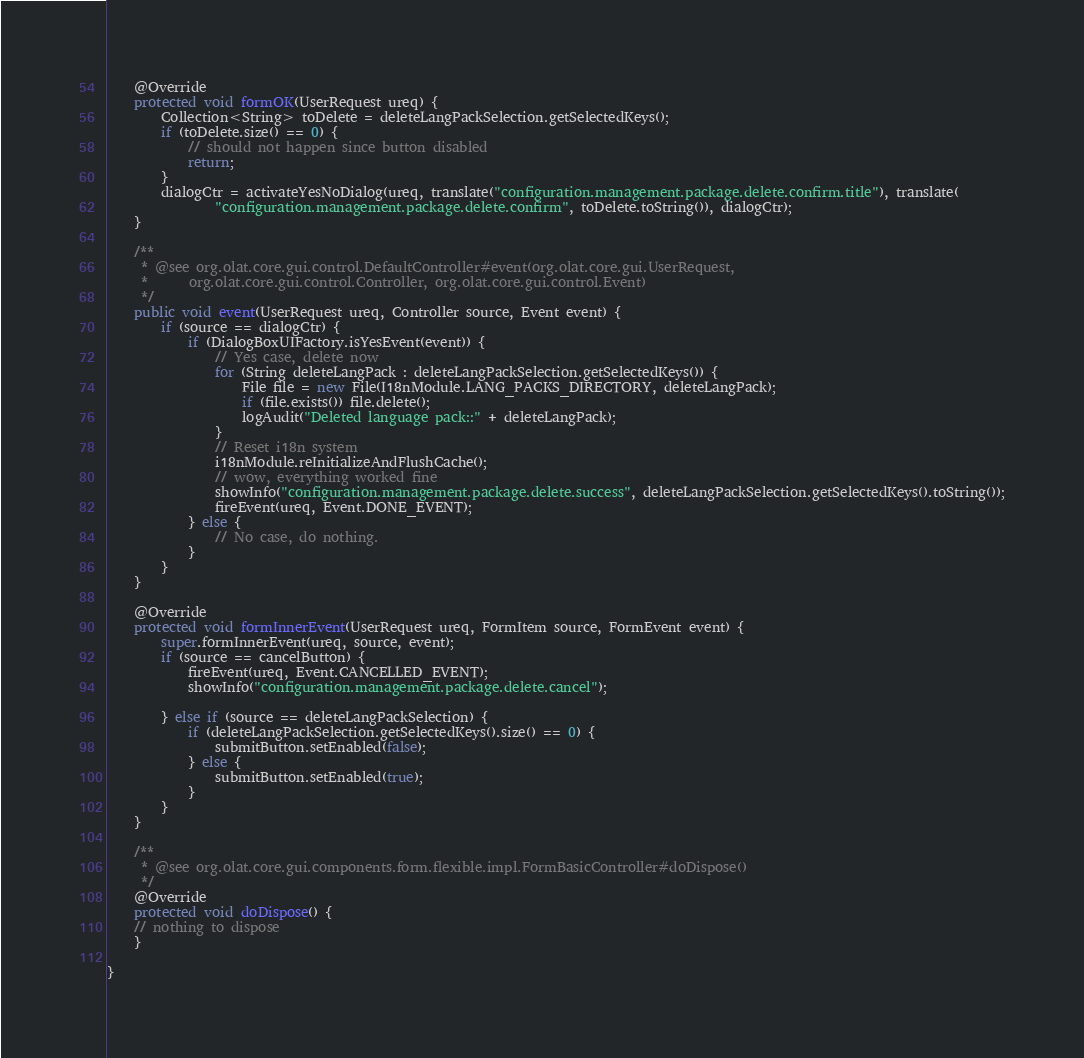<code> <loc_0><loc_0><loc_500><loc_500><_Java_>	@Override
	protected void formOK(UserRequest ureq) {
		Collection<String> toDelete = deleteLangPackSelection.getSelectedKeys();
		if (toDelete.size() == 0) {
			// should not happen since button disabled
			return;
		}
		dialogCtr = activateYesNoDialog(ureq, translate("configuration.management.package.delete.confirm.title"), translate(
				"configuration.management.package.delete.confirm", toDelete.toString()), dialogCtr);
	}

	/**
	 * @see org.olat.core.gui.control.DefaultController#event(org.olat.core.gui.UserRequest,
	 *      org.olat.core.gui.control.Controller, org.olat.core.gui.control.Event)
	 */
	public void event(UserRequest ureq, Controller source, Event event) {
		if (source == dialogCtr) {
			if (DialogBoxUIFactory.isYesEvent(event)) {
				// Yes case, delete now
				for (String deleteLangPack : deleteLangPackSelection.getSelectedKeys()) {
					File file = new File(I18nModule.LANG_PACKS_DIRECTORY, deleteLangPack);
					if (file.exists()) file.delete();
					logAudit("Deleted language pack::" + deleteLangPack);
				}
				// Reset i18n system
				i18nModule.reInitializeAndFlushCache();
				// wow, everything worked fine
				showInfo("configuration.management.package.delete.success", deleteLangPackSelection.getSelectedKeys().toString());
				fireEvent(ureq, Event.DONE_EVENT);
			} else {
				// No case, do nothing.
			}
		}
	}

	@Override
	protected void formInnerEvent(UserRequest ureq, FormItem source, FormEvent event) {
		super.formInnerEvent(ureq, source, event);
		if (source == cancelButton) {
			fireEvent(ureq, Event.CANCELLED_EVENT);
			showInfo("configuration.management.package.delete.cancel");

		} else if (source == deleteLangPackSelection) {
			if (deleteLangPackSelection.getSelectedKeys().size() == 0) {
				submitButton.setEnabled(false);
			} else {
				submitButton.setEnabled(true);
			}
		}
	}

	/**
	 * @see org.olat.core.gui.components.form.flexible.impl.FormBasicController#doDispose()
	 */
	@Override
	protected void doDispose() {
	// nothing to dispose
	}

}
</code> 